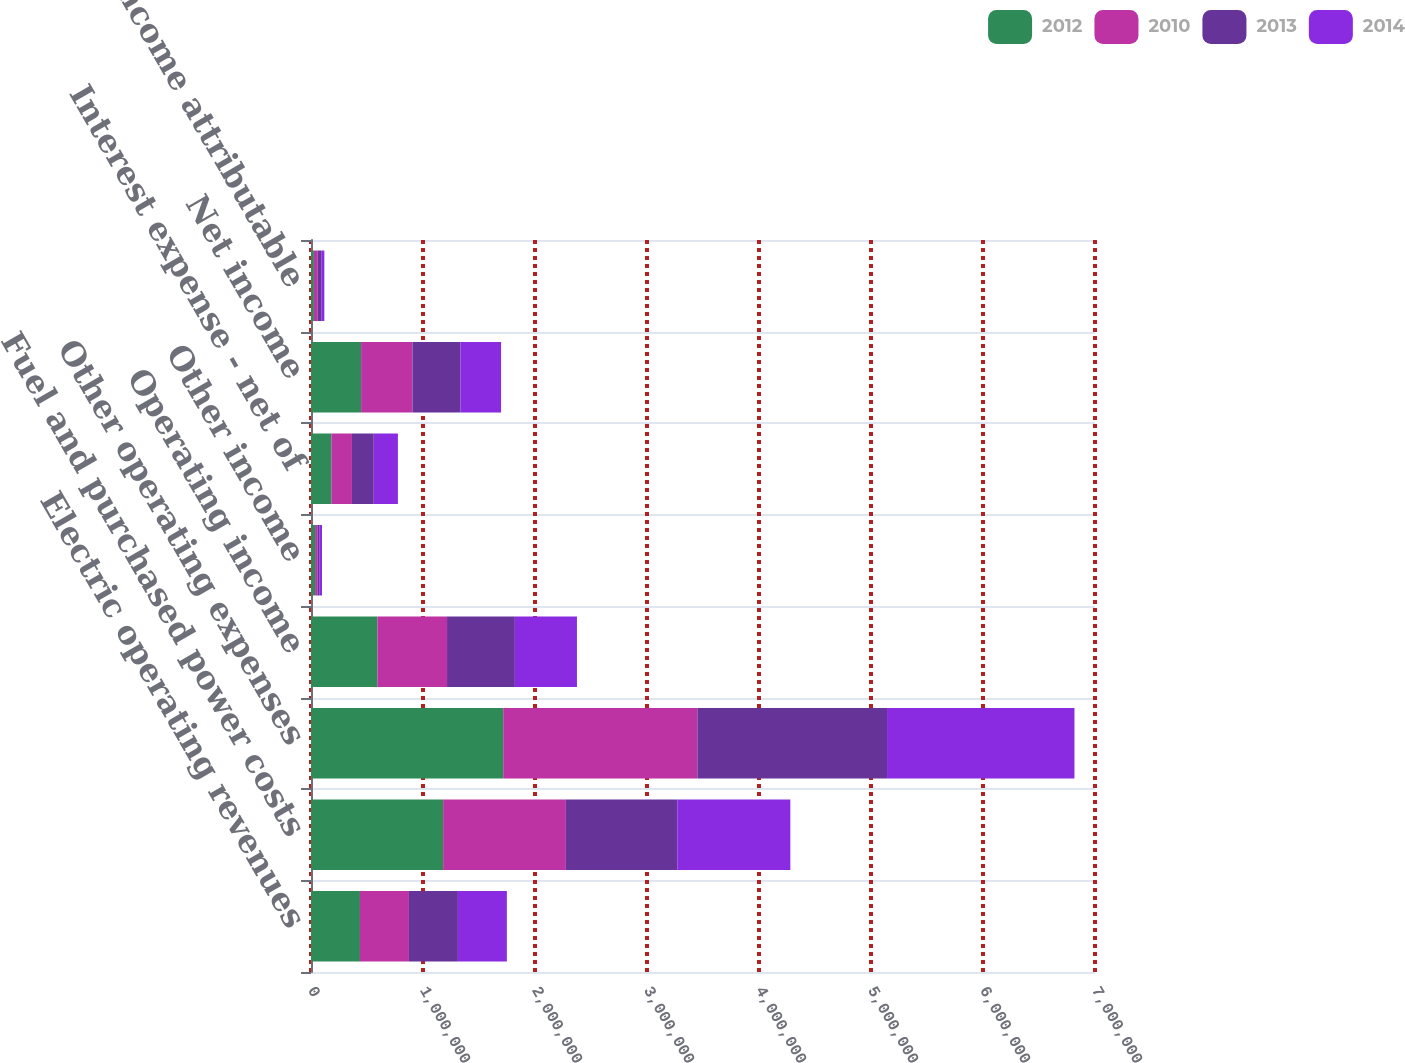Convert chart. <chart><loc_0><loc_0><loc_500><loc_500><stacked_bar_chart><ecel><fcel>Electric operating revenues<fcel>Fuel and purchased power costs<fcel>Other operating expenses<fcel>Operating income<fcel>Other income<fcel>Interest expense - net of<fcel>Net income<fcel>Less Net income attributable<nl><fcel>2012<fcel>437215<fcel>1.17983e+06<fcel>1.71632e+06<fcel>592792<fcel>36358<fcel>181830<fcel>447320<fcel>26101<nl><fcel>2010<fcel>437215<fcel>1.09571e+06<fcel>1.73368e+06<fcel>621865<fcel>20797<fcel>183801<fcel>458861<fcel>33892<nl><fcel>2013<fcel>437215<fcel>994790<fcel>1.69317e+06<fcel>605529<fcel>16358<fcel>194777<fcel>427110<fcel>31613<nl><fcel>2014<fcel>437215<fcel>1.00946e+06<fcel>1.67339e+06<fcel>554383<fcel>24974<fcel>215584<fcel>363773<fcel>27524<nl></chart> 